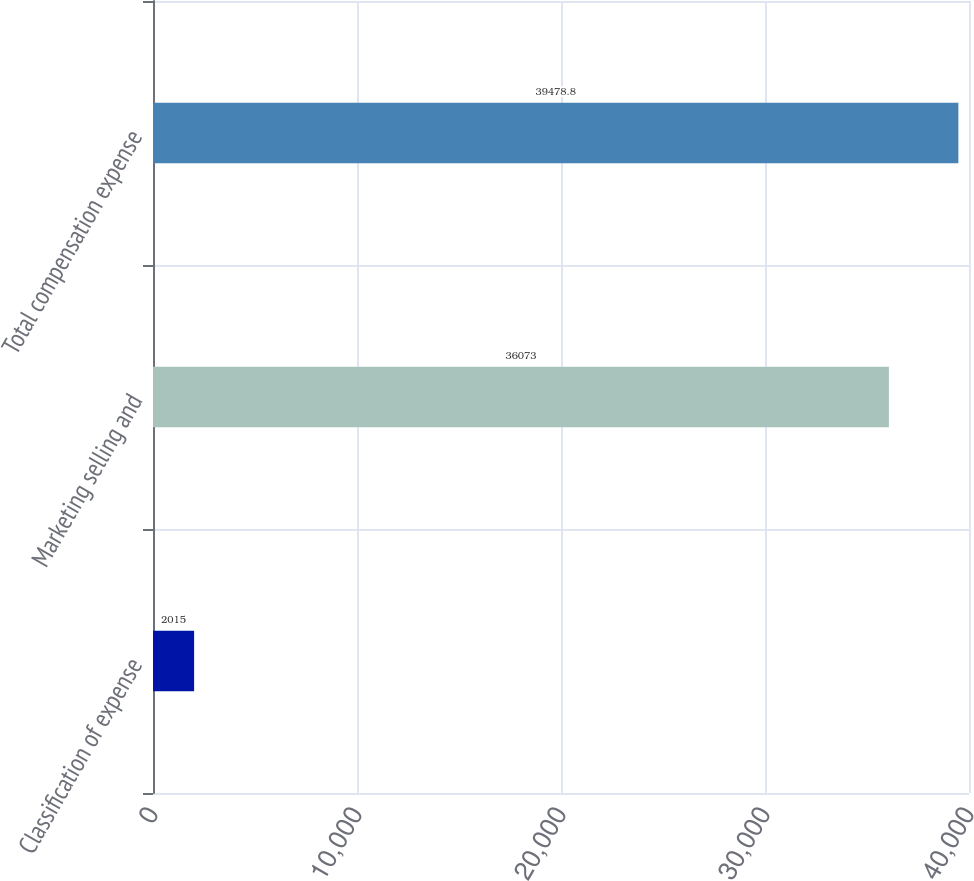Convert chart to OTSL. <chart><loc_0><loc_0><loc_500><loc_500><bar_chart><fcel>Classification of expense<fcel>Marketing selling and<fcel>Total compensation expense<nl><fcel>2015<fcel>36073<fcel>39478.8<nl></chart> 